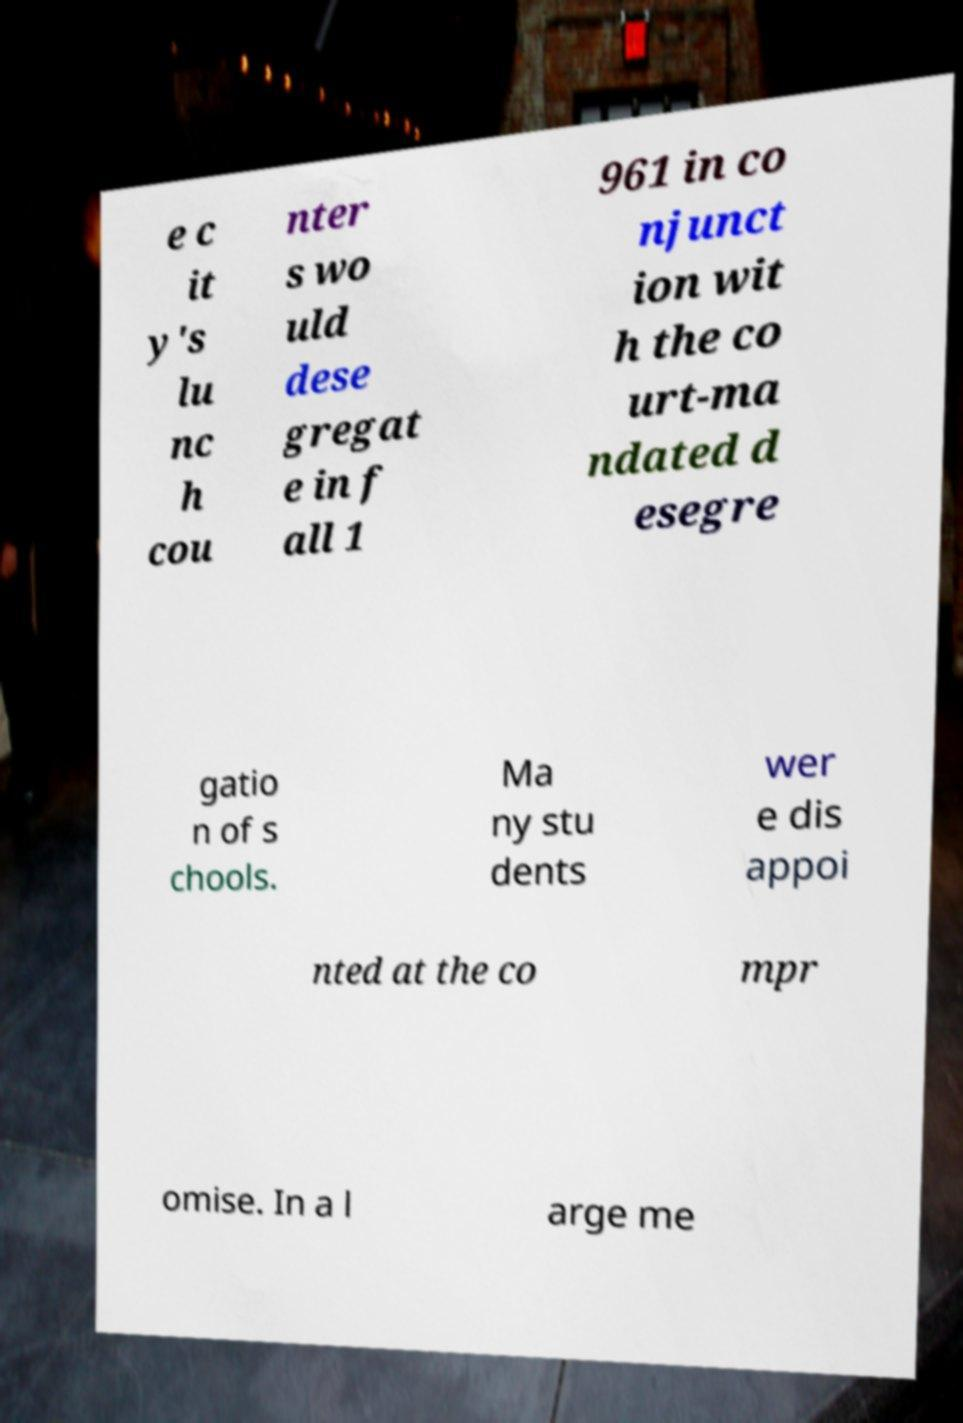Can you accurately transcribe the text from the provided image for me? e c it y's lu nc h cou nter s wo uld dese gregat e in f all 1 961 in co njunct ion wit h the co urt-ma ndated d esegre gatio n of s chools. Ma ny stu dents wer e dis appoi nted at the co mpr omise. In a l arge me 